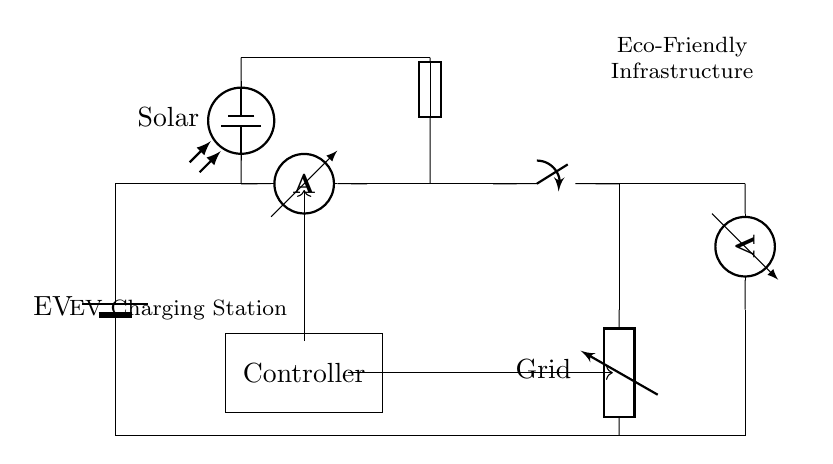What component represents the electric vehicle? The electric vehicle is represented by the battery labeled "EV". It can be identified at the leftmost part of the circuit diagram.
Answer: EV What is the role of the controller in this circuit? The controller is centrally located in the circuit, which likely manages the charging process and controls the flow of electricity to and from the electric vehicle.
Answer: Controller What components are used to generate energy for the electric vehicle charging station? The components generating energy for the charging station are the solar source and the grid connection, both of which supply power to the charging station.
Answer: Solar and Grid What is indicated by the ammeter in this circuit? The ammeter measures the current flowing through the circuit, which is critical for monitoring how much electricity is being supplied to the electric vehicle during charging.
Answer: Current How many main power sources are connected to the EV charging station? The circuit indicates that there are two main power sources: one from the solar panel and the other from the grid, allowing flexibility in charging options.
Answer: Two What function does the fuse serve in the circuit? The fuse protects the circuit by preventing overloads; if the current exceeds a certain threshold, the fuse will blow and stop the current flow, safeguarding components.
Answer: Protection What type of infrastructure does this circuit represent? This circuit represents eco-friendly charging infrastructure designed to utilize renewable energy sources alongside the grid.
Answer: Eco-Friendly Infrastructure 